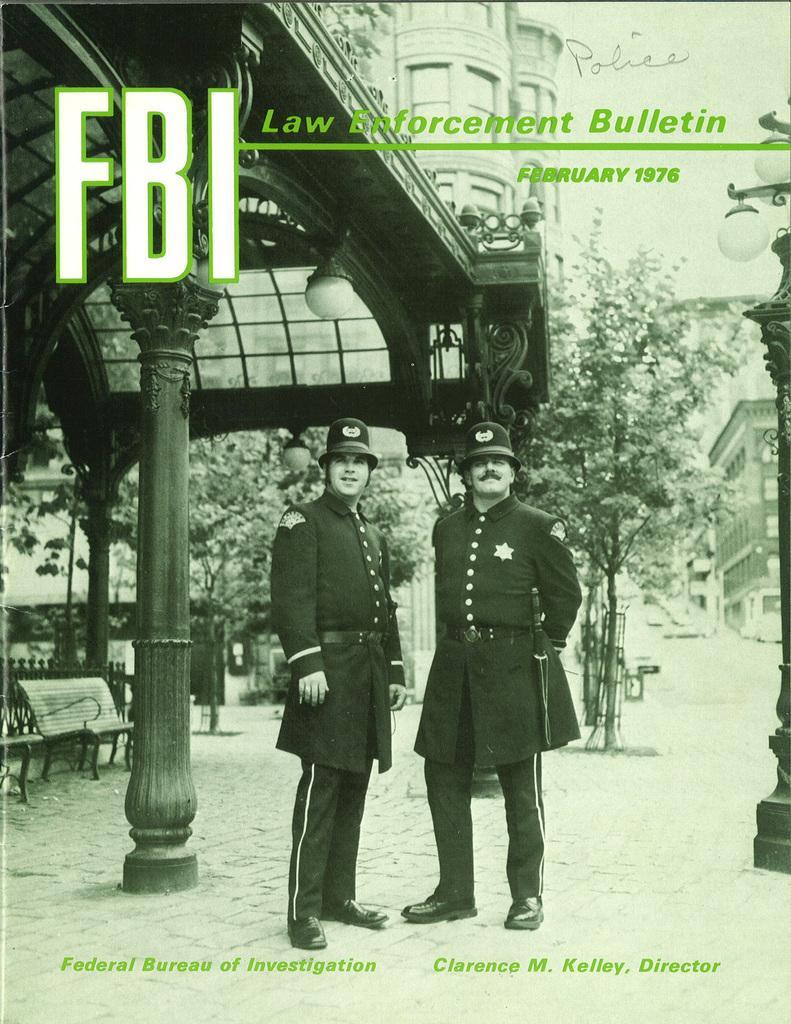In one or two sentences, can you explain what this image depicts? This is an edited picture. In this image there are two people standing. At the back there are buildings and trees and there are street lights. On the left side of the image there is a railing and there are benches. At the back there is an object on the wall. At the top there is sky and there is text. At the bottom there is a road and there is text. 